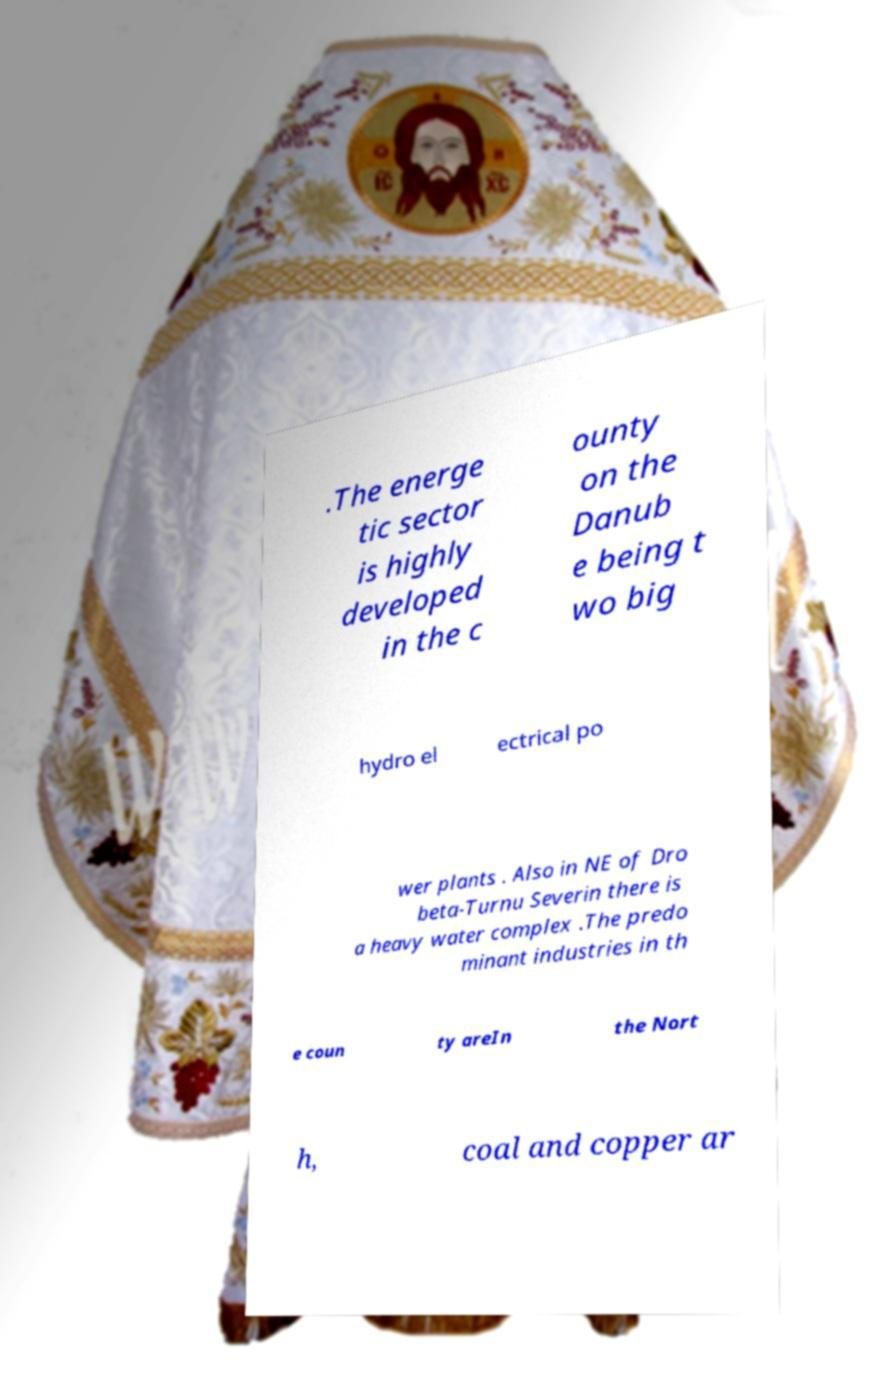There's text embedded in this image that I need extracted. Can you transcribe it verbatim? .The energe tic sector is highly developed in the c ounty on the Danub e being t wo big hydro el ectrical po wer plants . Also in NE of Dro beta-Turnu Severin there is a heavy water complex .The predo minant industries in th e coun ty areIn the Nort h, coal and copper ar 